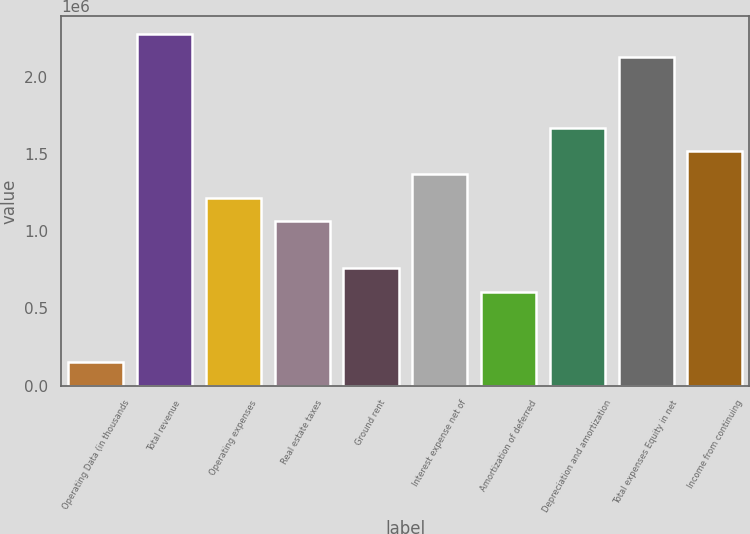<chart> <loc_0><loc_0><loc_500><loc_500><bar_chart><fcel>Operating Data (in thousands<fcel>Total revenue<fcel>Operating expenses<fcel>Real estate taxes<fcel>Ground rent<fcel>Interest expense net of<fcel>Amortization of deferred<fcel>Depreciation and amortization<fcel>Total expenses Equity in net<fcel>Income from continuing<nl><fcel>152003<fcel>2.27996e+06<fcel>1.21598e+06<fcel>1.06399e+06<fcel>759992<fcel>1.36798e+06<fcel>607994<fcel>1.67198e+06<fcel>2.12797e+06<fcel>1.51998e+06<nl></chart> 